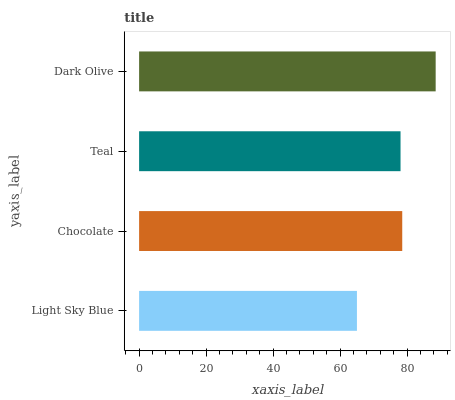Is Light Sky Blue the minimum?
Answer yes or no. Yes. Is Dark Olive the maximum?
Answer yes or no. Yes. Is Chocolate the minimum?
Answer yes or no. No. Is Chocolate the maximum?
Answer yes or no. No. Is Chocolate greater than Light Sky Blue?
Answer yes or no. Yes. Is Light Sky Blue less than Chocolate?
Answer yes or no. Yes. Is Light Sky Blue greater than Chocolate?
Answer yes or no. No. Is Chocolate less than Light Sky Blue?
Answer yes or no. No. Is Chocolate the high median?
Answer yes or no. Yes. Is Teal the low median?
Answer yes or no. Yes. Is Dark Olive the high median?
Answer yes or no. No. Is Chocolate the low median?
Answer yes or no. No. 